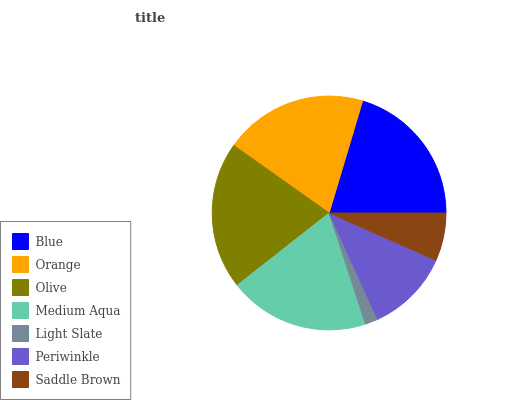Is Light Slate the minimum?
Answer yes or no. Yes. Is Olive the maximum?
Answer yes or no. Yes. Is Orange the minimum?
Answer yes or no. No. Is Orange the maximum?
Answer yes or no. No. Is Blue greater than Orange?
Answer yes or no. Yes. Is Orange less than Blue?
Answer yes or no. Yes. Is Orange greater than Blue?
Answer yes or no. No. Is Blue less than Orange?
Answer yes or no. No. Is Medium Aqua the high median?
Answer yes or no. Yes. Is Medium Aqua the low median?
Answer yes or no. Yes. Is Orange the high median?
Answer yes or no. No. Is Orange the low median?
Answer yes or no. No. 